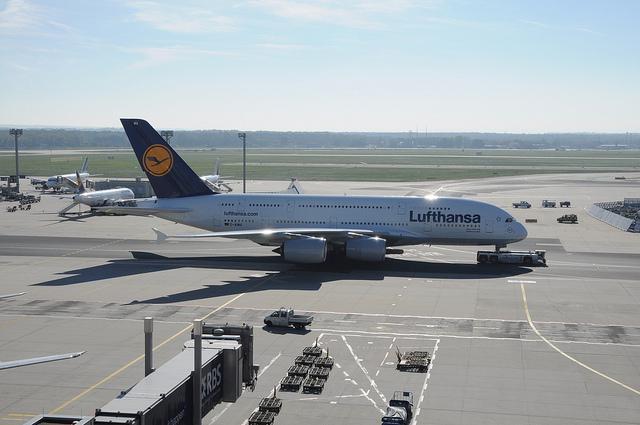How many airplanes can you see?
Give a very brief answer. 1. How many people are visible behind the man seated in blue?
Give a very brief answer. 0. 